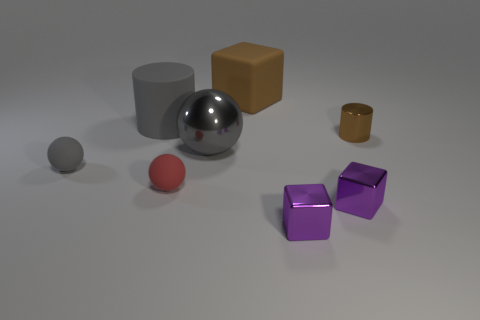Subtract all large cubes. How many cubes are left? 2 Subtract all purple cubes. How many cubes are left? 1 Subtract all blocks. How many objects are left? 5 Add 1 large metal spheres. How many objects exist? 9 Subtract 0 blue cylinders. How many objects are left? 8 Subtract 1 balls. How many balls are left? 2 Subtract all brown cylinders. Subtract all brown balls. How many cylinders are left? 1 Subtract all purple cylinders. How many red spheres are left? 1 Subtract all big matte things. Subtract all big red cylinders. How many objects are left? 6 Add 4 gray matte things. How many gray matte things are left? 6 